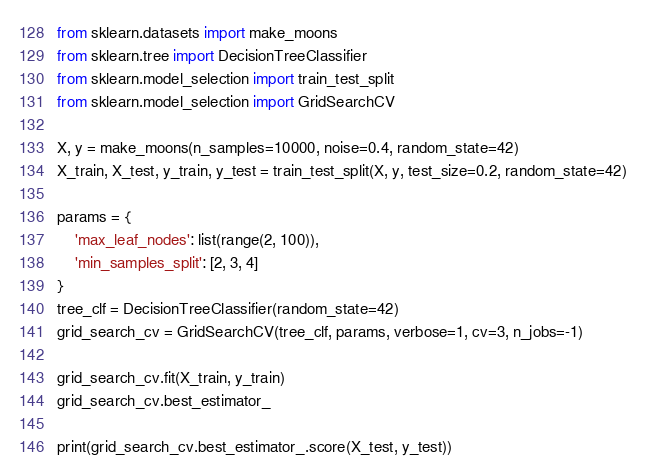<code> <loc_0><loc_0><loc_500><loc_500><_Python_>from sklearn.datasets import make_moons
from sklearn.tree import DecisionTreeClassifier
from sklearn.model_selection import train_test_split
from sklearn.model_selection import GridSearchCV

X, y = make_moons(n_samples=10000, noise=0.4, random_state=42)
X_train, X_test, y_train, y_test = train_test_split(X, y, test_size=0.2, random_state=42)

params = {
    'max_leaf_nodes': list(range(2, 100)), 
    'min_samples_split': [2, 3, 4]
}
tree_clf = DecisionTreeClassifier(random_state=42)
grid_search_cv = GridSearchCV(tree_clf, params, verbose=1, cv=3, n_jobs=-1)

grid_search_cv.fit(X_train, y_train)
grid_search_cv.best_estimator_

print(grid_search_cv.best_estimator_.score(X_test, y_test))
</code> 